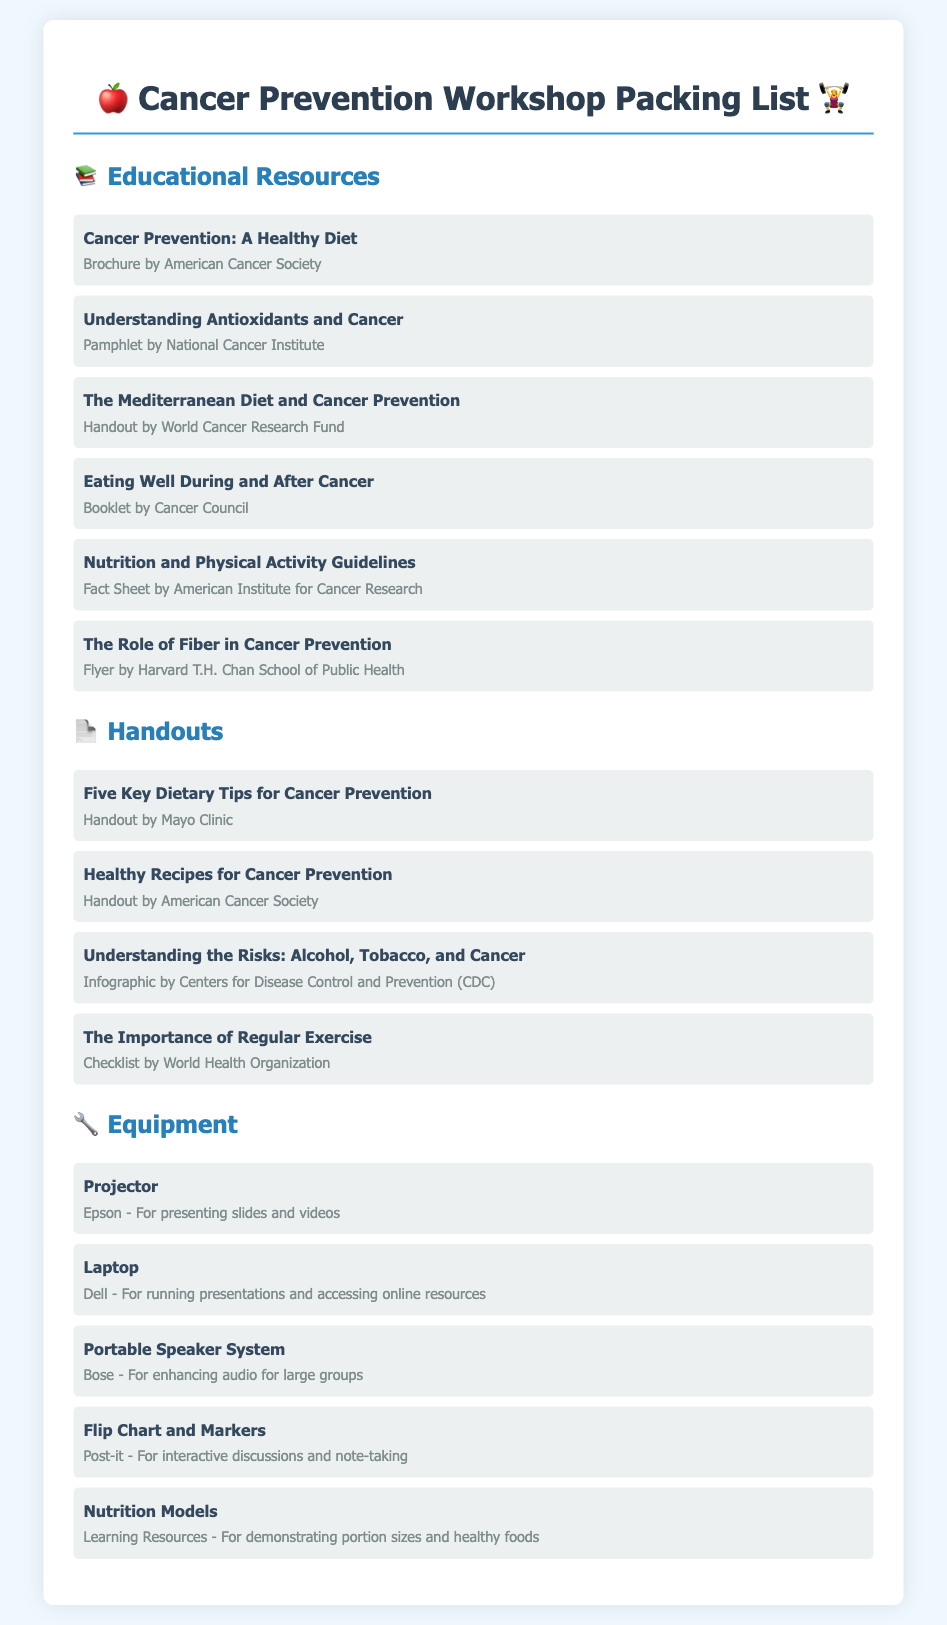What is the title of the first educational resource? The title of the first educational resource is "Cancer Prevention: A Healthy Diet."
Answer: Cancer Prevention: A Healthy Diet How many handouts are listed in the document? The document lists four handouts under the Handouts section.
Answer: 4 What type of item is the "Portable Speaker System"? The "Portable Speaker System" is categorized as Equipment in the document.
Answer: Equipment Who provided the "Healthy Recipes for Cancer Prevention" handout? The "Healthy Recipes for Cancer Prevention" handout is provided by the American Cancer Society.
Answer: American Cancer Society Which educational resource focuses on fiber? The educational resource that focuses on fiber is "The Role of Fiber in Cancer Prevention."
Answer: The Role of Fiber in Cancer Prevention What is the purpose of the Flip Chart and Markers? The Flip Chart and Markers are used for interactive discussions and note-taking.
Answer: Interactive discussions and note-taking How many educational resources are listed? There are six educational resources listed in the document.
Answer: 6 Which booklet is provided by Cancer Council? The booklet provided by Cancer Council is titled "Eating Well During and After Cancer."
Answer: Eating Well During and After Cancer What is the function of the projector listed? The projector is for presenting slides and videos.
Answer: Presenting slides and videos 